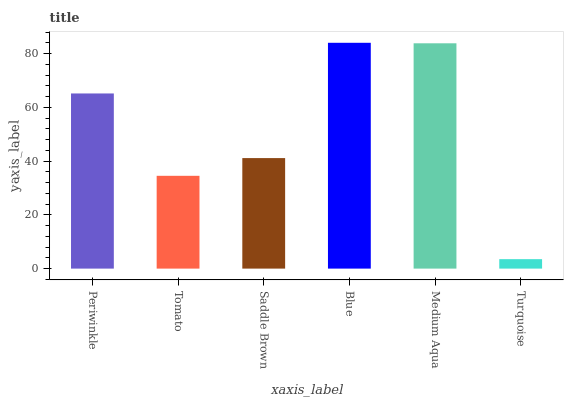Is Turquoise the minimum?
Answer yes or no. Yes. Is Blue the maximum?
Answer yes or no. Yes. Is Tomato the minimum?
Answer yes or no. No. Is Tomato the maximum?
Answer yes or no. No. Is Periwinkle greater than Tomato?
Answer yes or no. Yes. Is Tomato less than Periwinkle?
Answer yes or no. Yes. Is Tomato greater than Periwinkle?
Answer yes or no. No. Is Periwinkle less than Tomato?
Answer yes or no. No. Is Periwinkle the high median?
Answer yes or no. Yes. Is Saddle Brown the low median?
Answer yes or no. Yes. Is Blue the high median?
Answer yes or no. No. Is Tomato the low median?
Answer yes or no. No. 